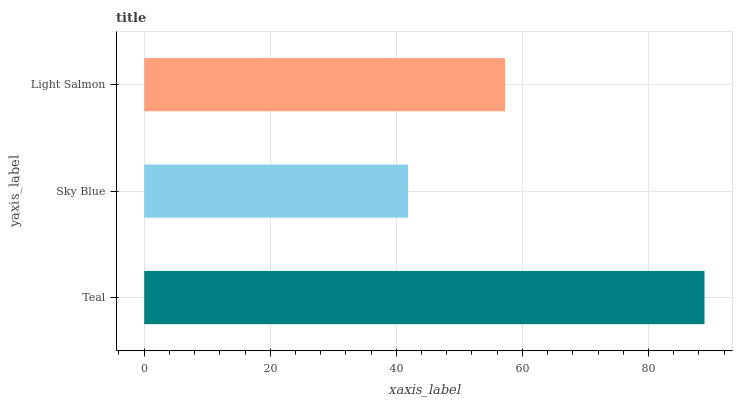Is Sky Blue the minimum?
Answer yes or no. Yes. Is Teal the maximum?
Answer yes or no. Yes. Is Light Salmon the minimum?
Answer yes or no. No. Is Light Salmon the maximum?
Answer yes or no. No. Is Light Salmon greater than Sky Blue?
Answer yes or no. Yes. Is Sky Blue less than Light Salmon?
Answer yes or no. Yes. Is Sky Blue greater than Light Salmon?
Answer yes or no. No. Is Light Salmon less than Sky Blue?
Answer yes or no. No. Is Light Salmon the high median?
Answer yes or no. Yes. Is Light Salmon the low median?
Answer yes or no. Yes. Is Teal the high median?
Answer yes or no. No. Is Teal the low median?
Answer yes or no. No. 